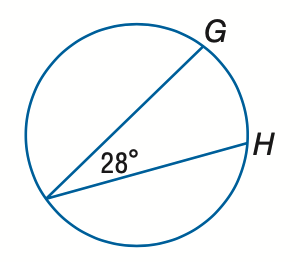Question: Find the measure of m \widehat G H.
Choices:
A. 28
B. 56
C. 84
D. 112
Answer with the letter. Answer: B 